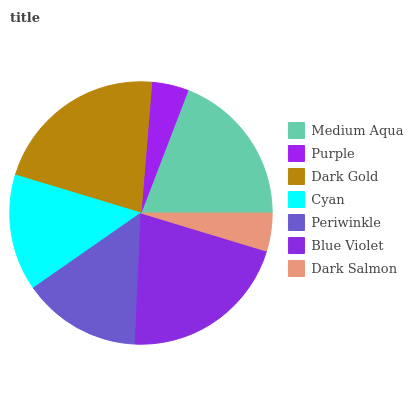Is Purple the minimum?
Answer yes or no. Yes. Is Dark Gold the maximum?
Answer yes or no. Yes. Is Dark Gold the minimum?
Answer yes or no. No. Is Purple the maximum?
Answer yes or no. No. Is Dark Gold greater than Purple?
Answer yes or no. Yes. Is Purple less than Dark Gold?
Answer yes or no. Yes. Is Purple greater than Dark Gold?
Answer yes or no. No. Is Dark Gold less than Purple?
Answer yes or no. No. Is Periwinkle the high median?
Answer yes or no. Yes. Is Periwinkle the low median?
Answer yes or no. Yes. Is Medium Aqua the high median?
Answer yes or no. No. Is Purple the low median?
Answer yes or no. No. 